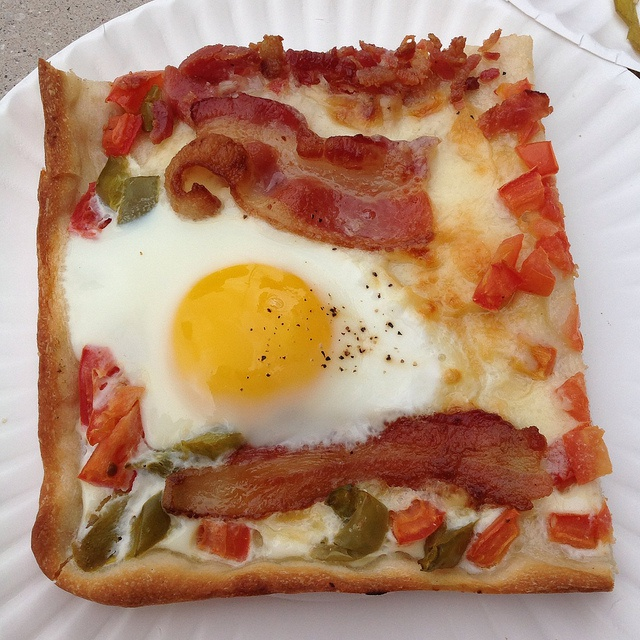Describe the objects in this image and their specific colors. I can see a pizza in darkgray, brown, maroon, and lightgray tones in this image. 